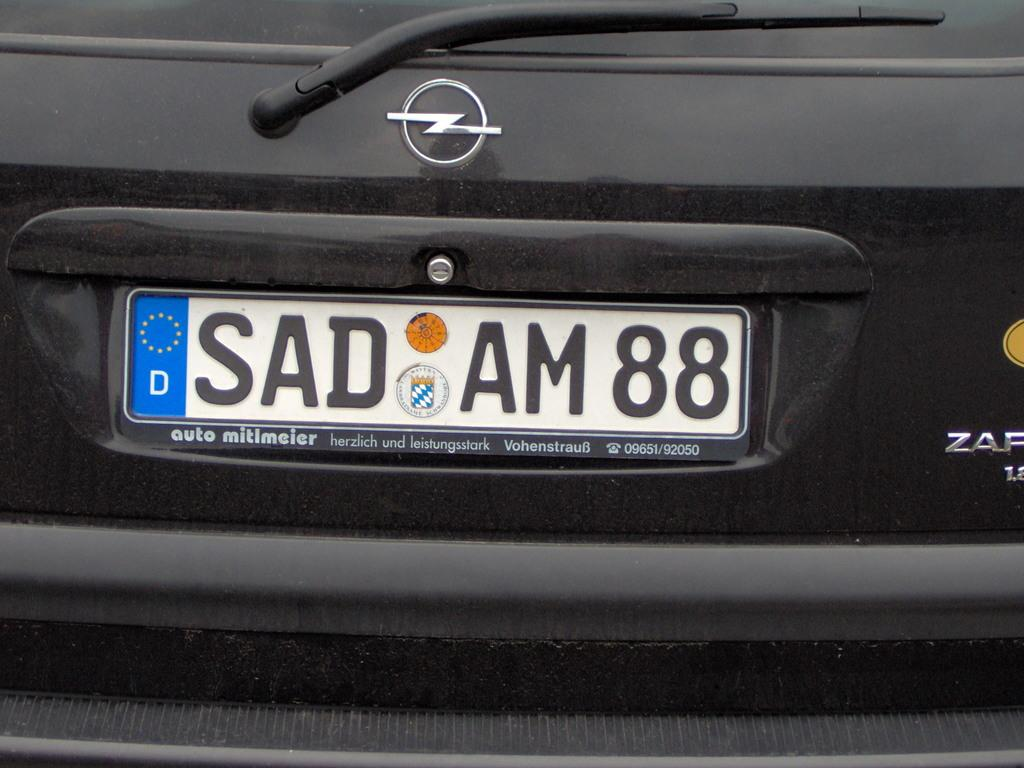<image>
Write a terse but informative summary of the picture. Black car with a white license plate that says SADAM88. 